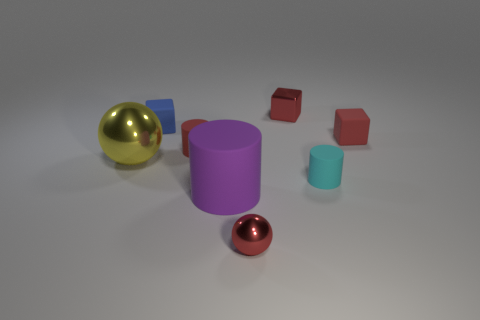Are there any other things that are the same size as the cyan thing?
Give a very brief answer. Yes. Is the shape of the matte thing behind the red rubber block the same as the big yellow thing that is behind the big matte object?
Give a very brief answer. No. There is a cyan matte thing that is the same size as the blue rubber cube; what shape is it?
Offer a terse response. Cylinder. Are there the same number of cyan cylinders behind the large yellow ball and small blocks that are to the right of the purple thing?
Ensure brevity in your answer.  No. Are there any other things that are the same shape as the big metal object?
Make the answer very short. Yes. Do the small cylinder left of the small red metal cube and the purple object have the same material?
Your response must be concise. Yes. There is a yellow ball that is the same size as the purple object; what material is it?
Your answer should be compact. Metal. How many other objects are the same material as the blue block?
Offer a very short reply. 4. Does the red rubber cylinder have the same size as the metallic sphere left of the tiny blue rubber block?
Provide a short and direct response. No. Are there fewer red rubber cylinders in front of the yellow shiny thing than metal balls that are behind the blue rubber cube?
Offer a terse response. No. 